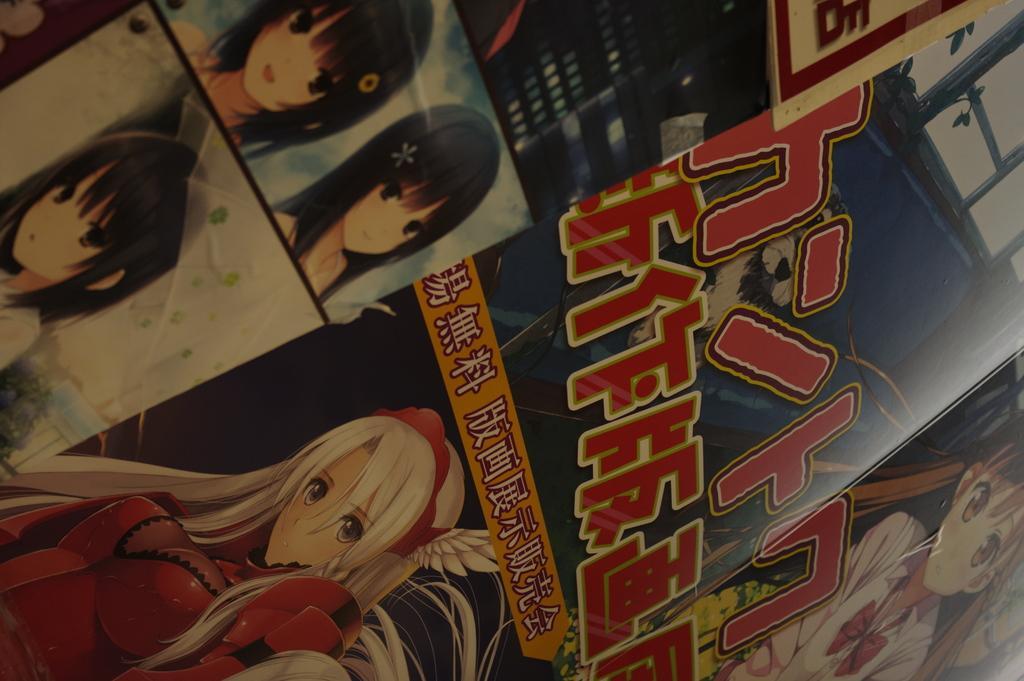Can you describe this image briefly? In this picture it looks like a cardboard box, there are words and cartoon characters on it. 